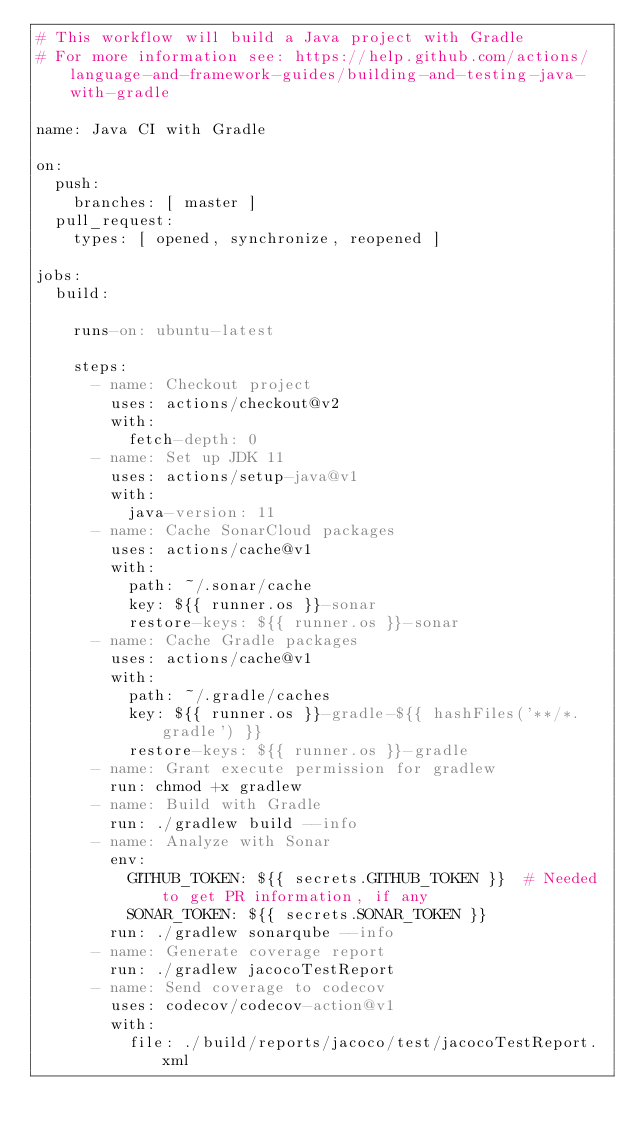<code> <loc_0><loc_0><loc_500><loc_500><_YAML_># This workflow will build a Java project with Gradle
# For more information see: https://help.github.com/actions/language-and-framework-guides/building-and-testing-java-with-gradle

name: Java CI with Gradle

on:
  push:
    branches: [ master ]
  pull_request:
    types: [ opened, synchronize, reopened ]

jobs:
  build:

    runs-on: ubuntu-latest

    steps:
      - name: Checkout project
        uses: actions/checkout@v2
        with:
          fetch-depth: 0
      - name: Set up JDK 11
        uses: actions/setup-java@v1
        with:
          java-version: 11
      - name: Cache SonarCloud packages
        uses: actions/cache@v1
        with:
          path: ~/.sonar/cache
          key: ${{ runner.os }}-sonar
          restore-keys: ${{ runner.os }}-sonar
      - name: Cache Gradle packages
        uses: actions/cache@v1
        with:
          path: ~/.gradle/caches
          key: ${{ runner.os }}-gradle-${{ hashFiles('**/*.gradle') }}
          restore-keys: ${{ runner.os }}-gradle
      - name: Grant execute permission for gradlew
        run: chmod +x gradlew
      - name: Build with Gradle
        run: ./gradlew build --info
      - name: Analyze with Sonar
        env:
          GITHUB_TOKEN: ${{ secrets.GITHUB_TOKEN }}  # Needed to get PR information, if any
          SONAR_TOKEN: ${{ secrets.SONAR_TOKEN }}
        run: ./gradlew sonarqube --info
      - name: Generate coverage report
        run: ./gradlew jacocoTestReport
      - name: Send coverage to codecov
        uses: codecov/codecov-action@v1
        with:
          file: ./build/reports/jacoco/test/jacocoTestReport.xml
</code> 